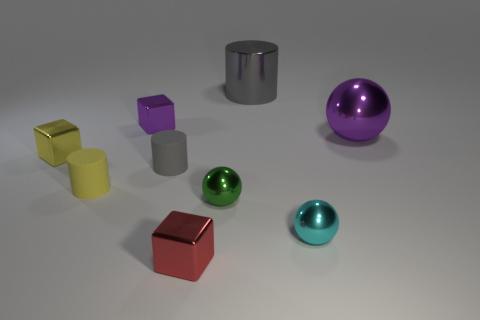What material is the object that is the same color as the big ball?
Your response must be concise. Metal. What shape is the small yellow object that is on the left side of the tiny yellow matte cylinder?
Ensure brevity in your answer.  Cube. There is another object that is the same size as the gray shiny thing; what is its material?
Your response must be concise. Metal. How many things are either cylinders that are behind the big purple object or things to the left of the large gray metal cylinder?
Ensure brevity in your answer.  7. What size is the cylinder that is made of the same material as the yellow cube?
Offer a very short reply. Large. How many metallic things are tiny purple blocks or balls?
Offer a terse response. 4. The purple metal sphere is what size?
Offer a terse response. Large. Is the size of the yellow metal cube the same as the metallic cylinder?
Ensure brevity in your answer.  No. There is a large thing that is in front of the big cylinder; what is it made of?
Your answer should be compact. Metal. There is a tiny green object that is the same shape as the cyan thing; what material is it?
Your answer should be very brief. Metal. 